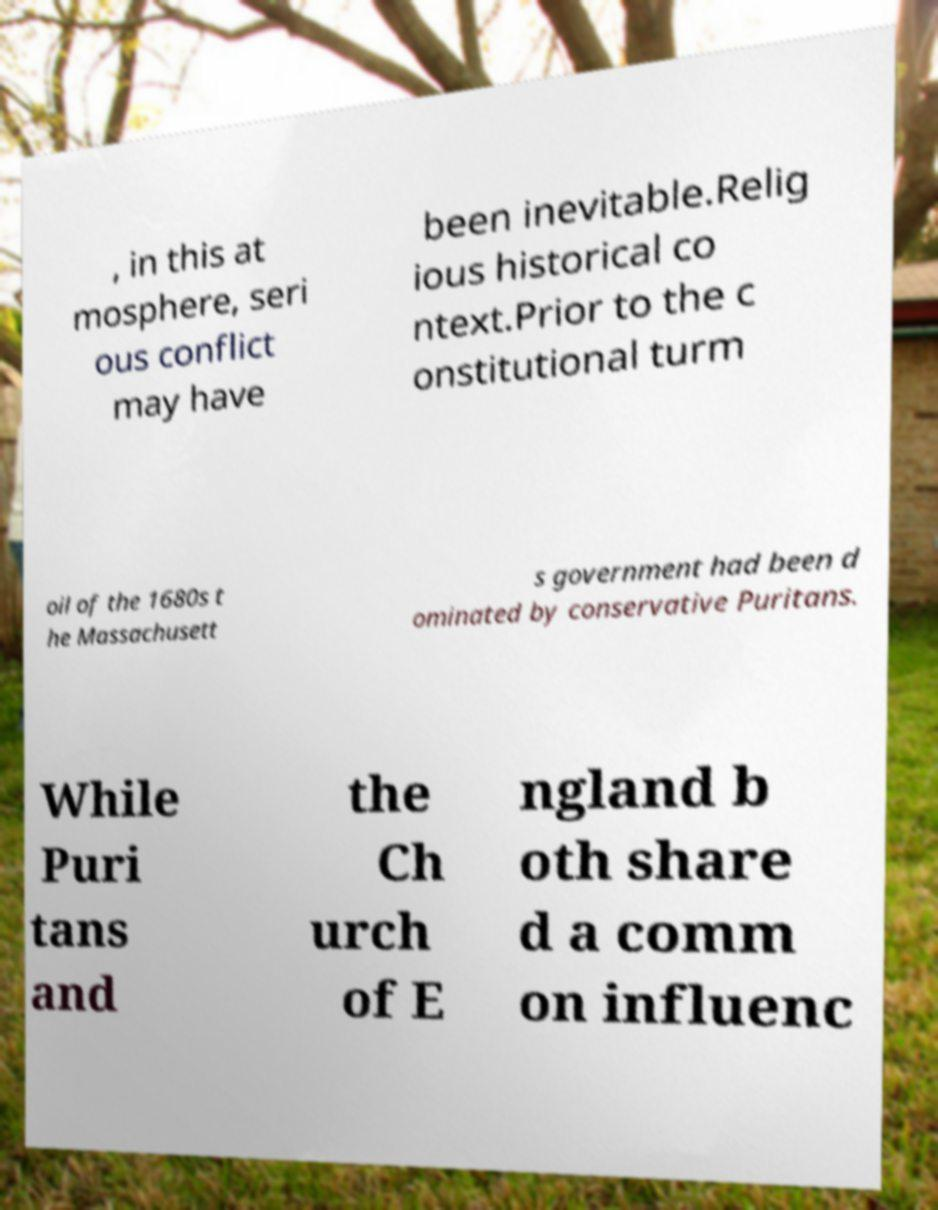Please read and relay the text visible in this image. What does it say? , in this at mosphere, seri ous conflict may have been inevitable.Relig ious historical co ntext.Prior to the c onstitutional turm oil of the 1680s t he Massachusett s government had been d ominated by conservative Puritans. While Puri tans and the Ch urch of E ngland b oth share d a comm on influenc 